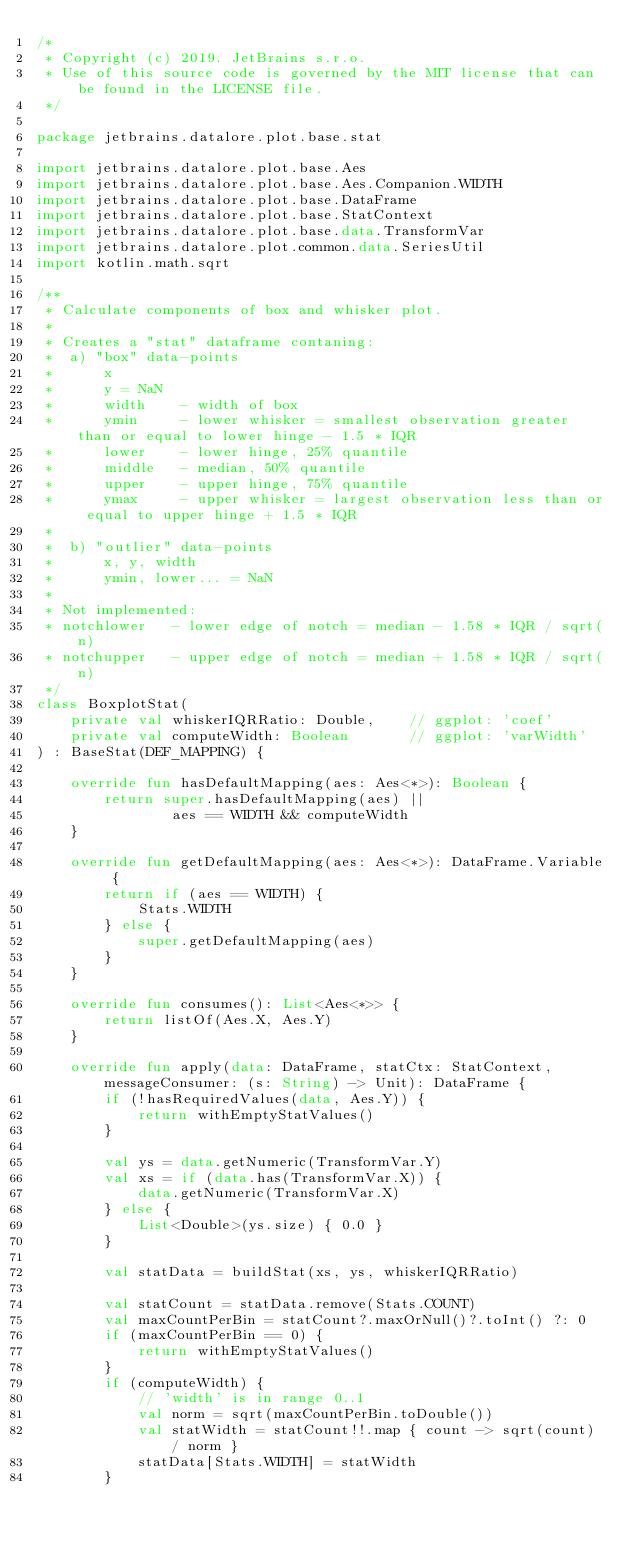<code> <loc_0><loc_0><loc_500><loc_500><_Kotlin_>/*
 * Copyright (c) 2019. JetBrains s.r.o.
 * Use of this source code is governed by the MIT license that can be found in the LICENSE file.
 */

package jetbrains.datalore.plot.base.stat

import jetbrains.datalore.plot.base.Aes
import jetbrains.datalore.plot.base.Aes.Companion.WIDTH
import jetbrains.datalore.plot.base.DataFrame
import jetbrains.datalore.plot.base.StatContext
import jetbrains.datalore.plot.base.data.TransformVar
import jetbrains.datalore.plot.common.data.SeriesUtil
import kotlin.math.sqrt

/**
 * Calculate components of box and whisker plot.
 *
 * Creates a "stat" dataframe contaning:
 *  a) "box" data-points
 *      x
 *      y = NaN
 *      width    - width of box
 *      ymin     - lower whisker = smallest observation greater than or equal to lower hinge - 1.5 * IQR
 *      lower    - lower hinge, 25% quantile
 *      middle   - median, 50% quantile
 *      upper    - upper hinge, 75% quantile
 *      ymax     - upper whisker = largest observation less than or equal to upper hinge + 1.5 * IQR
 *
 *  b) "outlier" data-points
 *      x, y, width
 *      ymin, lower... = NaN
 *
 * Not implemented:
 * notchlower   - lower edge of notch = median - 1.58 * IQR / sqrt(n)
 * notchupper   - upper edge of notch = median + 1.58 * IQR / sqrt(n)
 */
class BoxplotStat(
    private val whiskerIQRRatio: Double,    // ggplot: 'coef'
    private val computeWidth: Boolean       // ggplot: 'varWidth'
) : BaseStat(DEF_MAPPING) {

    override fun hasDefaultMapping(aes: Aes<*>): Boolean {
        return super.hasDefaultMapping(aes) ||
                aes == WIDTH && computeWidth
    }

    override fun getDefaultMapping(aes: Aes<*>): DataFrame.Variable {
        return if (aes == WIDTH) {
            Stats.WIDTH
        } else {
            super.getDefaultMapping(aes)
        }
    }

    override fun consumes(): List<Aes<*>> {
        return listOf(Aes.X, Aes.Y)
    }

    override fun apply(data: DataFrame, statCtx: StatContext, messageConsumer: (s: String) -> Unit): DataFrame {
        if (!hasRequiredValues(data, Aes.Y)) {
            return withEmptyStatValues()
        }

        val ys = data.getNumeric(TransformVar.Y)
        val xs = if (data.has(TransformVar.X)) {
            data.getNumeric(TransformVar.X)
        } else {
            List<Double>(ys.size) { 0.0 }
        }

        val statData = buildStat(xs, ys, whiskerIQRRatio)

        val statCount = statData.remove(Stats.COUNT)
        val maxCountPerBin = statCount?.maxOrNull()?.toInt() ?: 0
        if (maxCountPerBin == 0) {
            return withEmptyStatValues()
        }
        if (computeWidth) {
            // 'width' is in range 0..1
            val norm = sqrt(maxCountPerBin.toDouble())
            val statWidth = statCount!!.map { count -> sqrt(count) / norm }
            statData[Stats.WIDTH] = statWidth
        }
</code> 